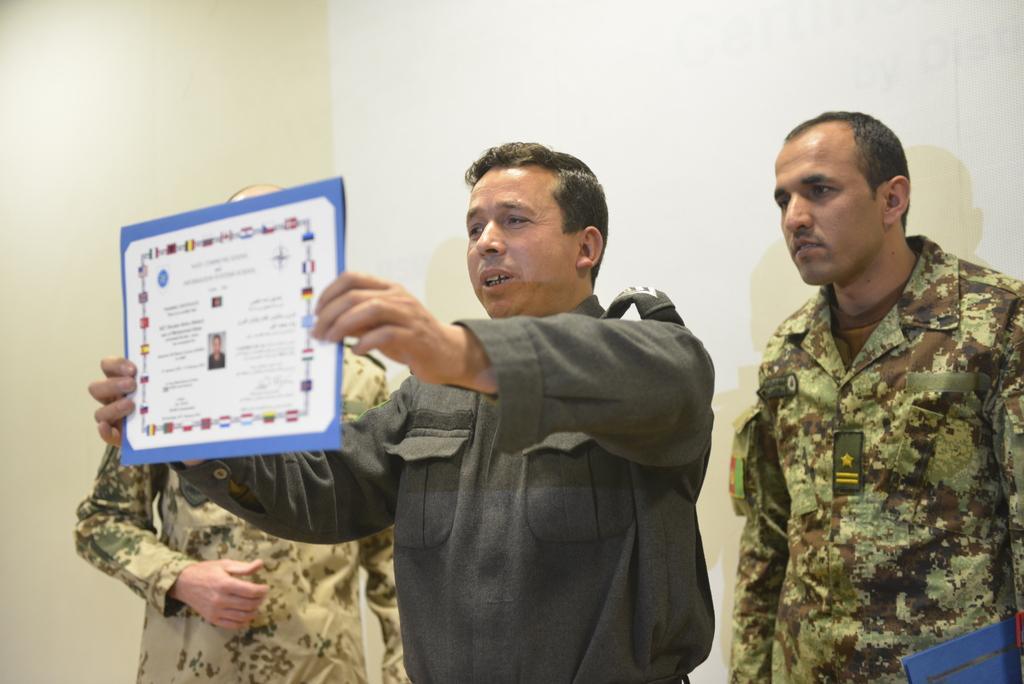Could you give a brief overview of what you see in this image? In this image I can see three persons walking, the person in front holding a board which is in white and blue color, and the person at right is wearing military dress. Background the wall is in white color. 